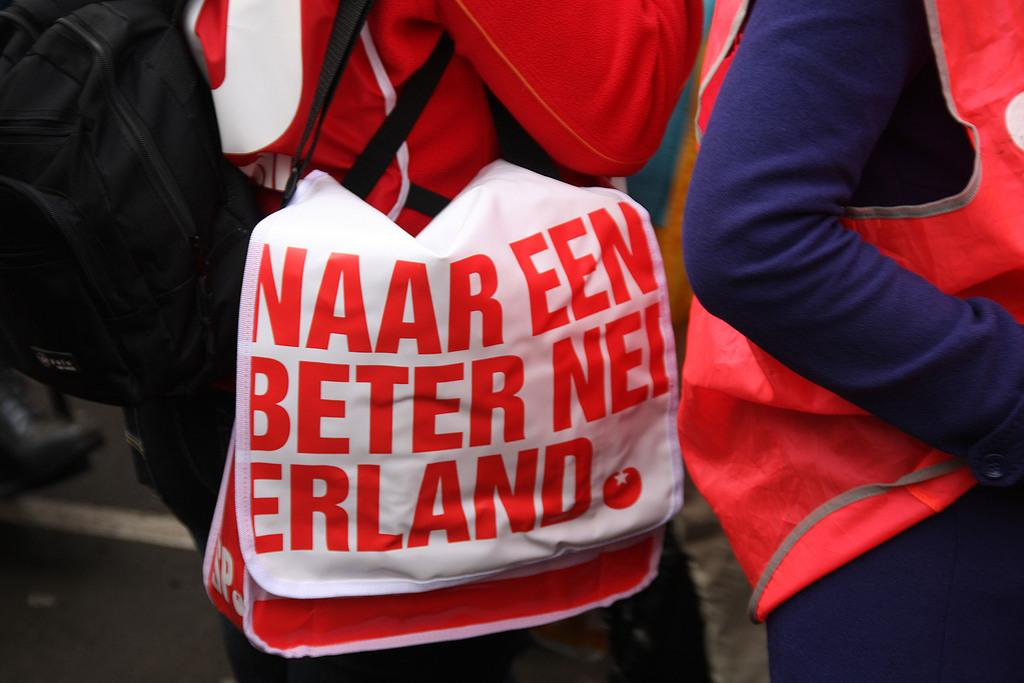<image>
Describe the image concisely. Person is holding a bag that have naar een beter nei erland wrote on it 